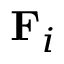Convert formula to latex. <formula><loc_0><loc_0><loc_500><loc_500>F _ { i }</formula> 